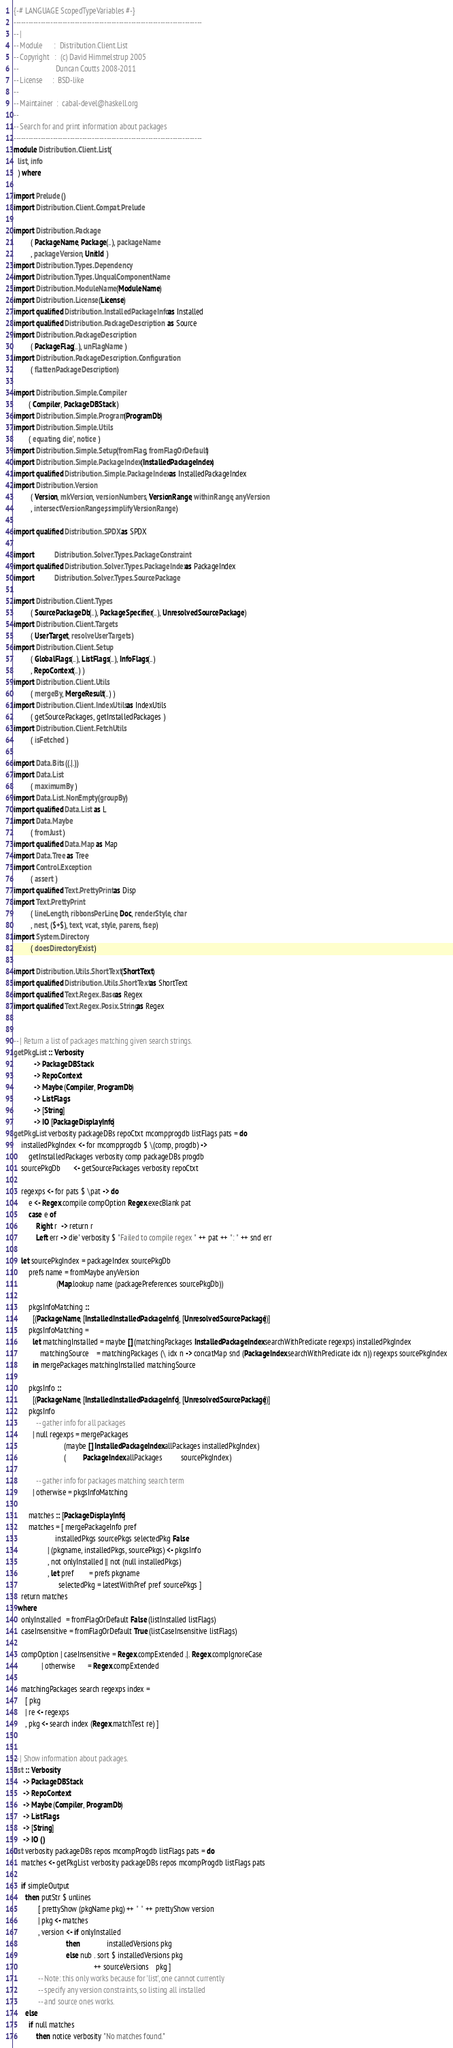<code> <loc_0><loc_0><loc_500><loc_500><_Haskell_>{-# LANGUAGE ScopedTypeVariables #-}
-----------------------------------------------------------------------------
-- |
-- Module      :  Distribution.Client.List
-- Copyright   :  (c) David Himmelstrup 2005
--                    Duncan Coutts 2008-2011
-- License     :  BSD-like
--
-- Maintainer  :  cabal-devel@haskell.org
--
-- Search for and print information about packages
-----------------------------------------------------------------------------
module Distribution.Client.List (
  list, info
  ) where

import Prelude ()
import Distribution.Client.Compat.Prelude

import Distribution.Package
         ( PackageName, Package(..), packageName
         , packageVersion, UnitId )
import Distribution.Types.Dependency
import Distribution.Types.UnqualComponentName
import Distribution.ModuleName (ModuleName)
import Distribution.License (License)
import qualified Distribution.InstalledPackageInfo as Installed
import qualified Distribution.PackageDescription   as Source
import Distribution.PackageDescription
         ( PackageFlag(..), unFlagName )
import Distribution.PackageDescription.Configuration
         ( flattenPackageDescription )

import Distribution.Simple.Compiler
        ( Compiler, PackageDBStack )
import Distribution.Simple.Program (ProgramDb)
import Distribution.Simple.Utils
        ( equating, die', notice )
import Distribution.Simple.Setup (fromFlag, fromFlagOrDefault)
import Distribution.Simple.PackageIndex (InstalledPackageIndex)
import qualified Distribution.Simple.PackageIndex as InstalledPackageIndex
import Distribution.Version
         ( Version, mkVersion, versionNumbers, VersionRange, withinRange, anyVersion
         , intersectVersionRanges, simplifyVersionRange )

import qualified Distribution.SPDX as SPDX

import           Distribution.Solver.Types.PackageConstraint
import qualified Distribution.Solver.Types.PackageIndex as PackageIndex
import           Distribution.Solver.Types.SourcePackage

import Distribution.Client.Types
         ( SourcePackageDb(..), PackageSpecifier(..), UnresolvedSourcePackage )
import Distribution.Client.Targets
         ( UserTarget, resolveUserTargets )
import Distribution.Client.Setup
         ( GlobalFlags(..), ListFlags(..), InfoFlags(..)
         , RepoContext(..) )
import Distribution.Client.Utils
         ( mergeBy, MergeResult(..) )
import Distribution.Client.IndexUtils as IndexUtils
         ( getSourcePackages, getInstalledPackages )
import Distribution.Client.FetchUtils
         ( isFetched )

import Data.Bits ((.|.))
import Data.List
         ( maximumBy )
import Data.List.NonEmpty (groupBy)
import qualified Data.List as L
import Data.Maybe
         ( fromJust )
import qualified Data.Map as Map
import Data.Tree as Tree
import Control.Exception
         ( assert )
import qualified Text.PrettyPrint as Disp
import Text.PrettyPrint
         ( lineLength, ribbonsPerLine, Doc, renderStyle, char
         , nest, ($+$), text, vcat, style, parens, fsep)
import System.Directory
         ( doesDirectoryExist )

import Distribution.Utils.ShortText (ShortText)
import qualified Distribution.Utils.ShortText as ShortText
import qualified Text.Regex.Base as Regex
import qualified Text.Regex.Posix.String as Regex


-- | Return a list of packages matching given search strings.
getPkgList :: Verbosity
           -> PackageDBStack
           -> RepoContext
           -> Maybe (Compiler, ProgramDb)
           -> ListFlags
           -> [String]
           -> IO [PackageDisplayInfo]
getPkgList verbosity packageDBs repoCtxt mcompprogdb listFlags pats = do
    installedPkgIndex <- for mcompprogdb $ \(comp, progdb) ->
        getInstalledPackages verbosity comp packageDBs progdb
    sourcePkgDb       <- getSourcePackages verbosity repoCtxt

    regexps <- for pats $ \pat -> do
        e <- Regex.compile compOption Regex.execBlank pat
        case e of
            Right r  -> return r
            Left err -> die' verbosity $ "Failed to compile regex " ++ pat ++ ": " ++ snd err

    let sourcePkgIndex = packageIndex sourcePkgDb
        prefs name = fromMaybe anyVersion
                       (Map.lookup name (packagePreferences sourcePkgDb))

        pkgsInfoMatching ::
          [(PackageName, [Installed.InstalledPackageInfo], [UnresolvedSourcePackage])]
        pkgsInfoMatching =
          let matchingInstalled = maybe [] (matchingPackages InstalledPackageIndex.searchWithPredicate regexps) installedPkgIndex
              matchingSource    = matchingPackages (\ idx n -> concatMap snd (PackageIndex.searchWithPredicate idx n)) regexps sourcePkgIndex
          in mergePackages matchingInstalled matchingSource

        pkgsInfo ::
          [(PackageName, [Installed.InstalledPackageInfo], [UnresolvedSourcePackage])]
        pkgsInfo
            -- gather info for all packages
          | null regexps = mergePackages
                           (maybe [] InstalledPackageIndex.allPackages installedPkgIndex)
                           (         PackageIndex.allPackages          sourcePkgIndex)

            -- gather info for packages matching search term
          | otherwise = pkgsInfoMatching

        matches :: [PackageDisplayInfo]
        matches = [ mergePackageInfo pref
                      installedPkgs sourcePkgs selectedPkg False
                  | (pkgname, installedPkgs, sourcePkgs) <- pkgsInfo
                  , not onlyInstalled || not (null installedPkgs)
                  , let pref        = prefs pkgname
                        selectedPkg = latestWithPref pref sourcePkgs ]
    return matches
  where
    onlyInstalled   = fromFlagOrDefault False (listInstalled listFlags)
    caseInsensitive = fromFlagOrDefault True (listCaseInsensitive listFlags)

    compOption | caseInsensitive = Regex.compExtended .|. Regex.compIgnoreCase
               | otherwise       = Regex.compExtended

    matchingPackages search regexps index =
      [ pkg
      | re <- regexps
      , pkg <- search index (Regex.matchTest re) ]


-- | Show information about packages.
list :: Verbosity
     -> PackageDBStack
     -> RepoContext
     -> Maybe (Compiler, ProgramDb)
     -> ListFlags
     -> [String]
     -> IO ()
list verbosity packageDBs repos mcompProgdb listFlags pats = do
    matches <- getPkgList verbosity packageDBs repos mcompProgdb listFlags pats

    if simpleOutput
      then putStr $ unlines
             [ prettyShow (pkgName pkg) ++ " " ++ prettyShow version
             | pkg <- matches
             , version <- if onlyInstalled
                            then              installedVersions pkg
                            else nub . sort $ installedVersions pkg
                                           ++ sourceVersions    pkg ]
             -- Note: this only works because for 'list', one cannot currently
             -- specify any version constraints, so listing all installed
             -- and source ones works.
      else
        if null matches
            then notice verbosity "No matches found."</code> 